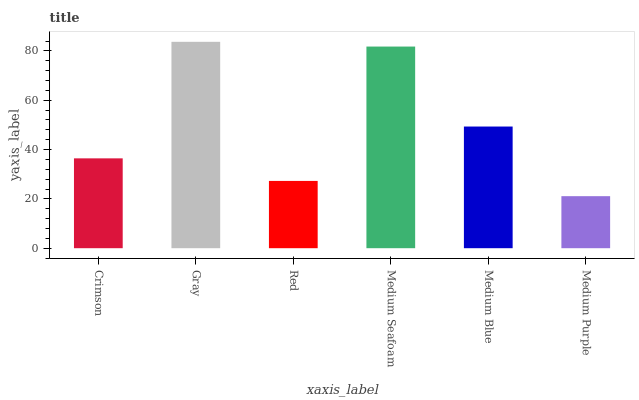Is Medium Purple the minimum?
Answer yes or no. Yes. Is Gray the maximum?
Answer yes or no. Yes. Is Red the minimum?
Answer yes or no. No. Is Red the maximum?
Answer yes or no. No. Is Gray greater than Red?
Answer yes or no. Yes. Is Red less than Gray?
Answer yes or no. Yes. Is Red greater than Gray?
Answer yes or no. No. Is Gray less than Red?
Answer yes or no. No. Is Medium Blue the high median?
Answer yes or no. Yes. Is Crimson the low median?
Answer yes or no. Yes. Is Red the high median?
Answer yes or no. No. Is Red the low median?
Answer yes or no. No. 